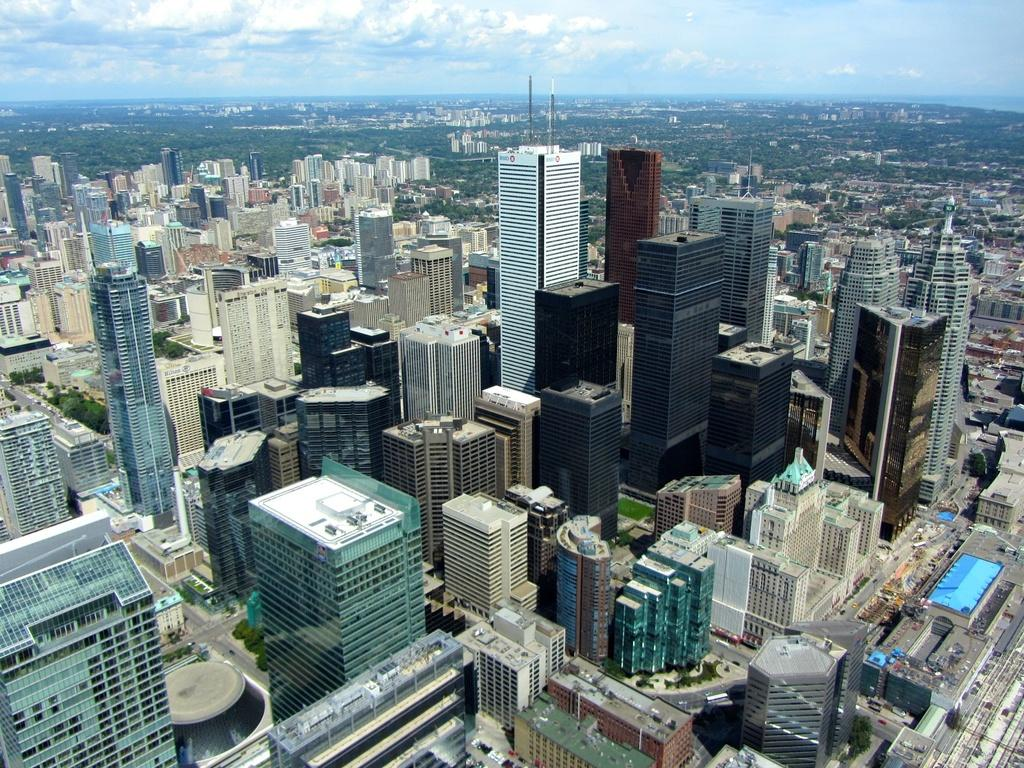What type of view is shown in the image? The image is an aerial view. What structures can be seen in the image? There are buildings in the image. What type of infrastructure is visible in the image? There are roads visible in the image. What can be seen in the background of the image? The sky and trees are visible in the background of the image. What type of prose is being taught in the image? There is no indication of teaching or prose in the image; it is an aerial view of buildings, roads, sky, and trees. 